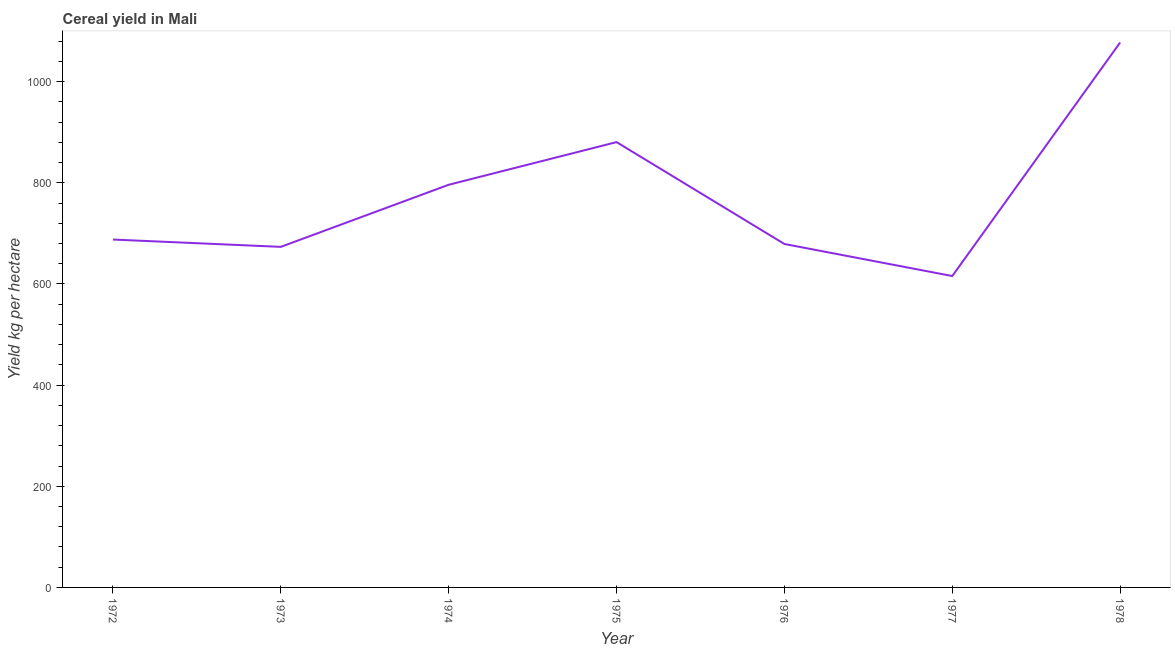What is the cereal yield in 1973?
Offer a very short reply. 673.43. Across all years, what is the maximum cereal yield?
Provide a short and direct response. 1077.52. Across all years, what is the minimum cereal yield?
Make the answer very short. 615.73. In which year was the cereal yield maximum?
Your answer should be very brief. 1978. In which year was the cereal yield minimum?
Your answer should be very brief. 1977. What is the sum of the cereal yield?
Make the answer very short. 5410.41. What is the difference between the cereal yield in 1972 and 1977?
Offer a very short reply. 72.16. What is the average cereal yield per year?
Ensure brevity in your answer.  772.92. What is the median cereal yield?
Offer a terse response. 687.88. In how many years, is the cereal yield greater than 560 kg per hectare?
Give a very brief answer. 7. Do a majority of the years between 1977 and 1972 (inclusive) have cereal yield greater than 640 kg per hectare?
Your answer should be compact. Yes. What is the ratio of the cereal yield in 1973 to that in 1978?
Give a very brief answer. 0.62. What is the difference between the highest and the second highest cereal yield?
Provide a succinct answer. 196.96. Is the sum of the cereal yield in 1973 and 1975 greater than the maximum cereal yield across all years?
Your answer should be very brief. Yes. What is the difference between the highest and the lowest cereal yield?
Ensure brevity in your answer.  461.79. In how many years, is the cereal yield greater than the average cereal yield taken over all years?
Keep it short and to the point. 3. How many lines are there?
Offer a terse response. 1. What is the title of the graph?
Keep it short and to the point. Cereal yield in Mali. What is the label or title of the Y-axis?
Make the answer very short. Yield kg per hectare. What is the Yield kg per hectare of 1972?
Offer a terse response. 687.88. What is the Yield kg per hectare of 1973?
Your response must be concise. 673.43. What is the Yield kg per hectare in 1974?
Provide a succinct answer. 796.19. What is the Yield kg per hectare of 1975?
Your answer should be very brief. 880.55. What is the Yield kg per hectare in 1976?
Offer a very short reply. 679.11. What is the Yield kg per hectare in 1977?
Make the answer very short. 615.73. What is the Yield kg per hectare in 1978?
Provide a succinct answer. 1077.52. What is the difference between the Yield kg per hectare in 1972 and 1973?
Ensure brevity in your answer.  14.46. What is the difference between the Yield kg per hectare in 1972 and 1974?
Provide a short and direct response. -108.31. What is the difference between the Yield kg per hectare in 1972 and 1975?
Offer a very short reply. -192.67. What is the difference between the Yield kg per hectare in 1972 and 1976?
Provide a short and direct response. 8.77. What is the difference between the Yield kg per hectare in 1972 and 1977?
Ensure brevity in your answer.  72.16. What is the difference between the Yield kg per hectare in 1972 and 1978?
Provide a succinct answer. -389.63. What is the difference between the Yield kg per hectare in 1973 and 1974?
Your answer should be compact. -122.77. What is the difference between the Yield kg per hectare in 1973 and 1975?
Keep it short and to the point. -207.13. What is the difference between the Yield kg per hectare in 1973 and 1976?
Make the answer very short. -5.68. What is the difference between the Yield kg per hectare in 1973 and 1977?
Give a very brief answer. 57.7. What is the difference between the Yield kg per hectare in 1973 and 1978?
Ensure brevity in your answer.  -404.09. What is the difference between the Yield kg per hectare in 1974 and 1975?
Offer a very short reply. -84.36. What is the difference between the Yield kg per hectare in 1974 and 1976?
Provide a succinct answer. 117.08. What is the difference between the Yield kg per hectare in 1974 and 1977?
Make the answer very short. 180.46. What is the difference between the Yield kg per hectare in 1974 and 1978?
Make the answer very short. -281.32. What is the difference between the Yield kg per hectare in 1975 and 1976?
Keep it short and to the point. 201.44. What is the difference between the Yield kg per hectare in 1975 and 1977?
Your answer should be compact. 264.82. What is the difference between the Yield kg per hectare in 1975 and 1978?
Your answer should be very brief. -196.96. What is the difference between the Yield kg per hectare in 1976 and 1977?
Ensure brevity in your answer.  63.38. What is the difference between the Yield kg per hectare in 1976 and 1978?
Keep it short and to the point. -398.41. What is the difference between the Yield kg per hectare in 1977 and 1978?
Your answer should be compact. -461.79. What is the ratio of the Yield kg per hectare in 1972 to that in 1973?
Give a very brief answer. 1.02. What is the ratio of the Yield kg per hectare in 1972 to that in 1974?
Offer a very short reply. 0.86. What is the ratio of the Yield kg per hectare in 1972 to that in 1975?
Provide a succinct answer. 0.78. What is the ratio of the Yield kg per hectare in 1972 to that in 1976?
Offer a terse response. 1.01. What is the ratio of the Yield kg per hectare in 1972 to that in 1977?
Offer a very short reply. 1.12. What is the ratio of the Yield kg per hectare in 1972 to that in 1978?
Give a very brief answer. 0.64. What is the ratio of the Yield kg per hectare in 1973 to that in 1974?
Provide a short and direct response. 0.85. What is the ratio of the Yield kg per hectare in 1973 to that in 1975?
Make the answer very short. 0.77. What is the ratio of the Yield kg per hectare in 1973 to that in 1976?
Keep it short and to the point. 0.99. What is the ratio of the Yield kg per hectare in 1973 to that in 1977?
Make the answer very short. 1.09. What is the ratio of the Yield kg per hectare in 1974 to that in 1975?
Give a very brief answer. 0.9. What is the ratio of the Yield kg per hectare in 1974 to that in 1976?
Your answer should be compact. 1.17. What is the ratio of the Yield kg per hectare in 1974 to that in 1977?
Ensure brevity in your answer.  1.29. What is the ratio of the Yield kg per hectare in 1974 to that in 1978?
Provide a short and direct response. 0.74. What is the ratio of the Yield kg per hectare in 1975 to that in 1976?
Your answer should be very brief. 1.3. What is the ratio of the Yield kg per hectare in 1975 to that in 1977?
Provide a short and direct response. 1.43. What is the ratio of the Yield kg per hectare in 1975 to that in 1978?
Make the answer very short. 0.82. What is the ratio of the Yield kg per hectare in 1976 to that in 1977?
Keep it short and to the point. 1.1. What is the ratio of the Yield kg per hectare in 1976 to that in 1978?
Your answer should be compact. 0.63. What is the ratio of the Yield kg per hectare in 1977 to that in 1978?
Make the answer very short. 0.57. 